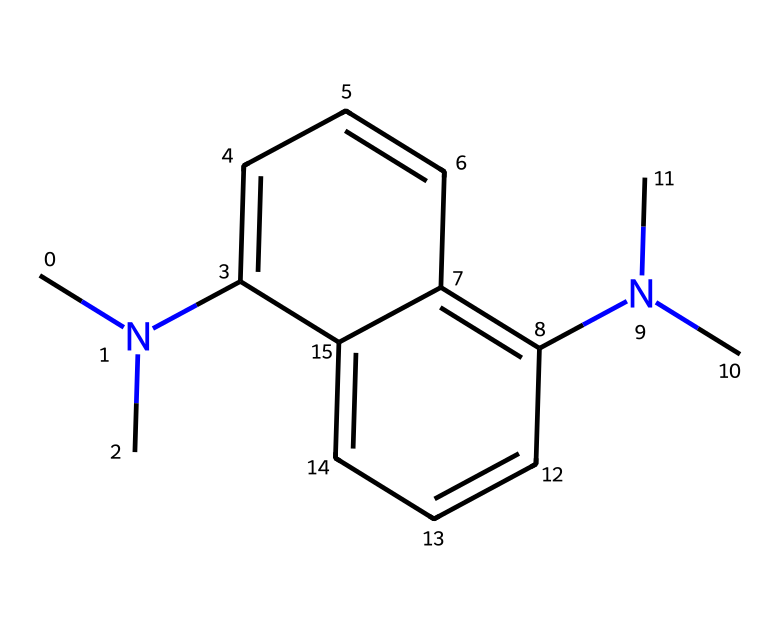What is the molecular formula of this superbase? To derive the molecular formula, count each type of atom present in the SMILES structure. The nitrogen (N) atoms are present twice, the carbon (C) atoms summed up add up to 18, and there are also 22 hydrogen (H) atoms. Thus, the molecular formula is C18H22N2.
Answer: C18H22N2 How many nitrogen atoms are in this superbase? From the SMILES representation, one can clearly see two instances of 'N', indicating there are two nitrogen atoms present.
Answer: 2 What type of bonding most likely exists between the carbon atoms in this chemical? Given the structure involves carbon atoms arranged in rings and a branching pattern, it's inferred that carbon atoms are bonded through covalent bonds, specifically sp2 hybridized due to the aromatic nature within the structure.
Answer: covalent What characteristic does the presence of two tertiary amines suggest about the basicity of the superbase? The presence of two tertiary amines (which feature nitrogen atoms connected to three carbon groups) suggests higher basicity and electron-donating capacity, as tertiary amines can stabilize positive charges more effectively than primary or secondary amines.
Answer: higher basicity In what type of extraction processes could this superbase be utilized? Considering the basic properties and strong protonation ability of this superbase, it is likely utilized in acid-base extraction processes, especially in extracting metal ions like titanium from their ores.
Answer: acid-base extraction What is the significance of the aromatic rings in this chemical structure? The presence of aromatic rings adds stability to the molecule due to resonance. This stability can affect the reactivity and overall basicity, making it more advantageous for use as a superbase in certain extraction processes.
Answer: stability through resonance 